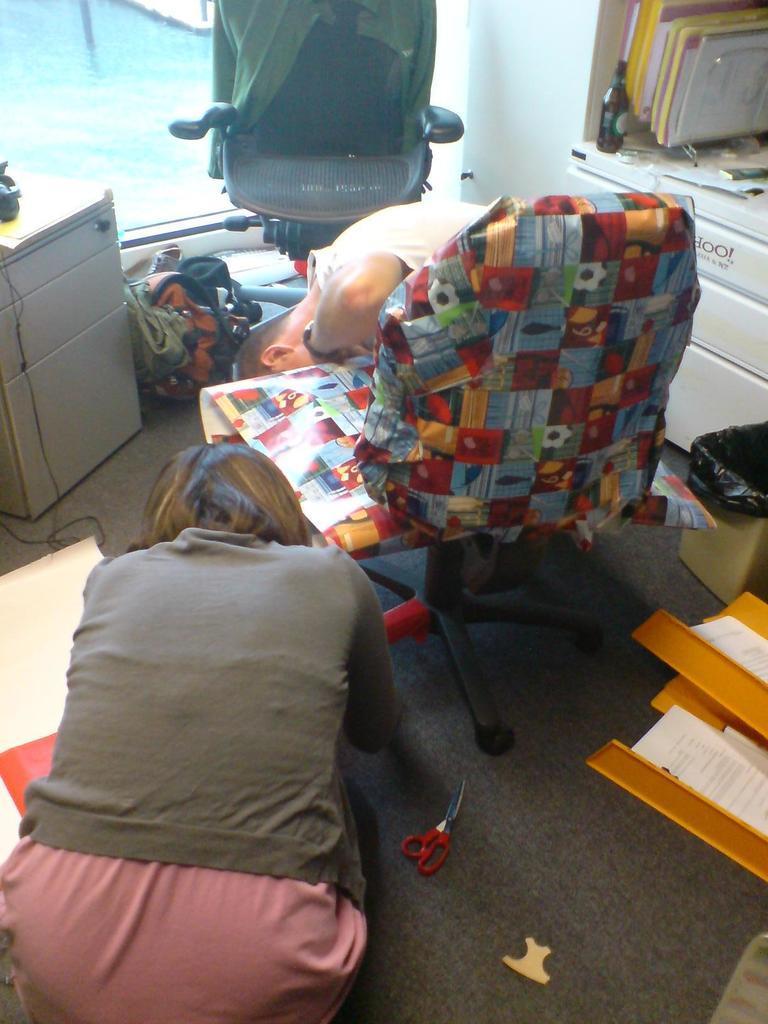In one or two sentences, can you explain what this image depicts? this picture shows two chairs and two people and few books and a scissors 